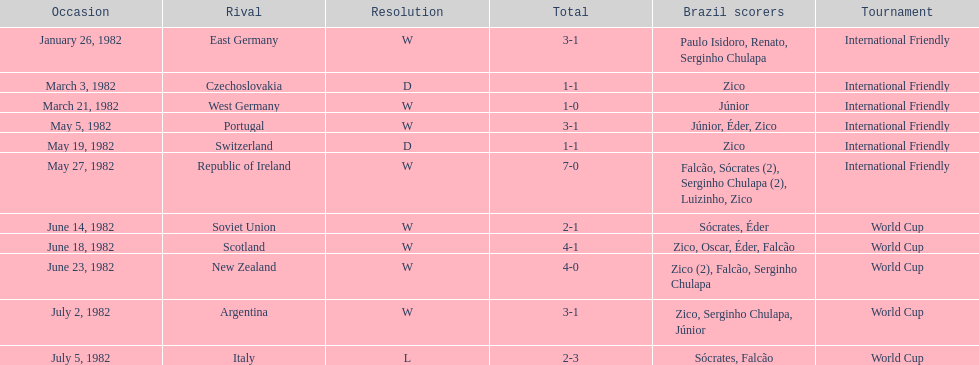What is the number of games won by brazil during the month of march 1982? 1. 